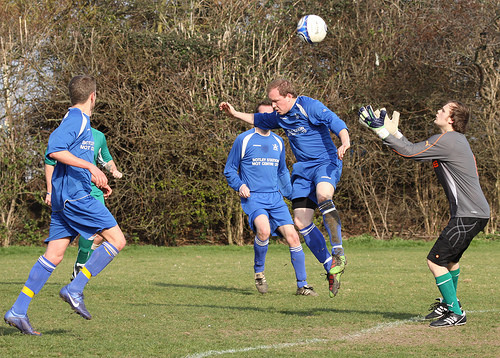<image>
Is there a soccer ball in the hands? No. The soccer ball is not contained within the hands. These objects have a different spatial relationship. 